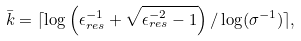<formula> <loc_0><loc_0><loc_500><loc_500>\bar { k } = \lceil \log \left ( \epsilon _ { r e s } ^ { - 1 } + \sqrt { \epsilon _ { r e s } ^ { - 2 } - 1 } \right ) / \log ( \sigma ^ { - 1 } ) \rceil ,</formula> 